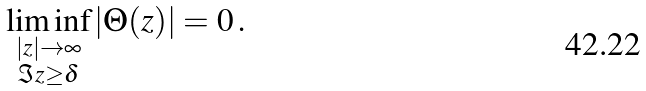Convert formula to latex. <formula><loc_0><loc_0><loc_500><loc_500>\liminf _ { \substack { | z | \to \infty \\ \Im z \geq \delta } } | \Theta ( z ) | = 0 \, .</formula> 